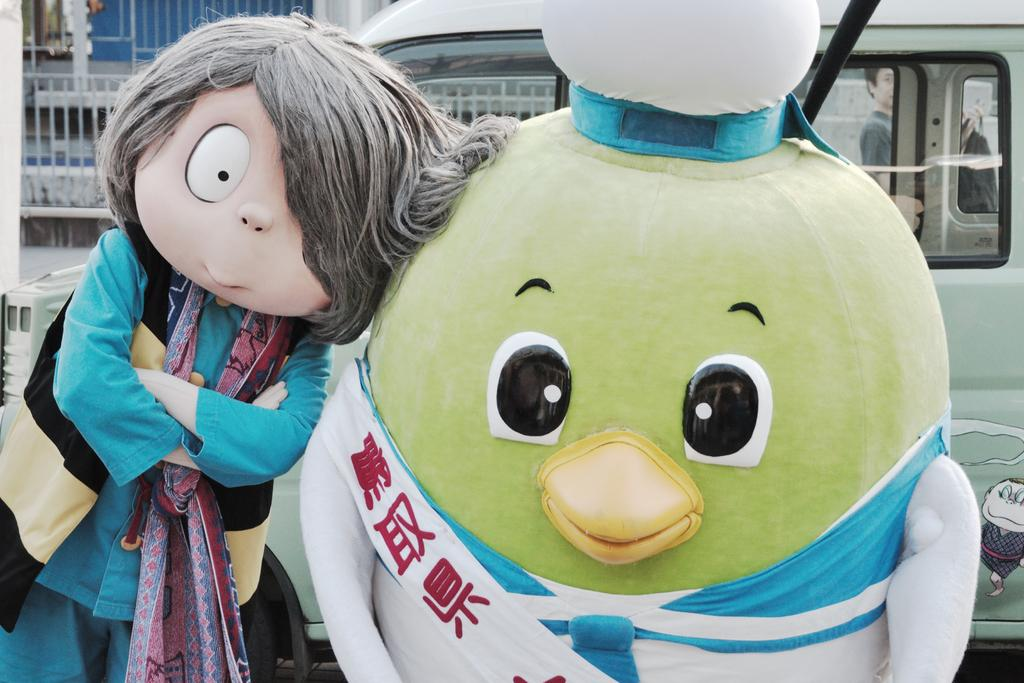What objects are in front of the vehicle in the image? There are toys in front of the vehicle in the image. What can be seen in the background of the image? There is a railing and a person in the background of the image. What type of skate is being used by the person in the image? There is no skate present in the image; the person is in the background behind the vehicle. What type of muscle is visible on the person in the image? There is no visible muscle on the person in the image, as the person is in the background behind the vehicle. 